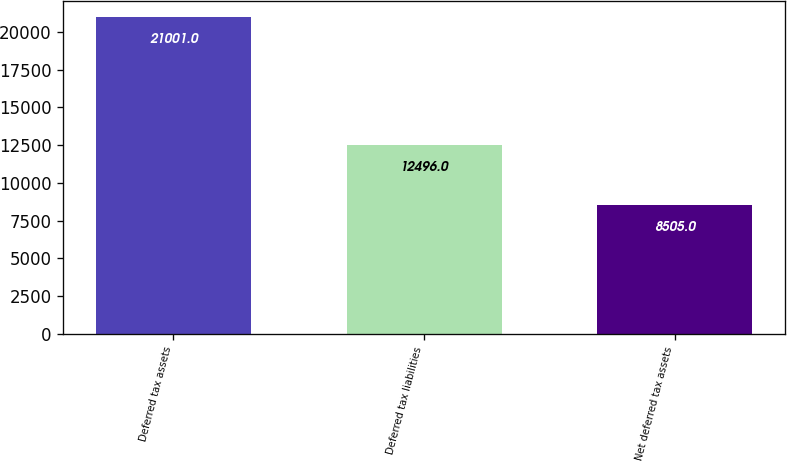Convert chart. <chart><loc_0><loc_0><loc_500><loc_500><bar_chart><fcel>Deferred tax assets<fcel>Deferred tax liabilities<fcel>Net deferred tax assets<nl><fcel>21001<fcel>12496<fcel>8505<nl></chart> 